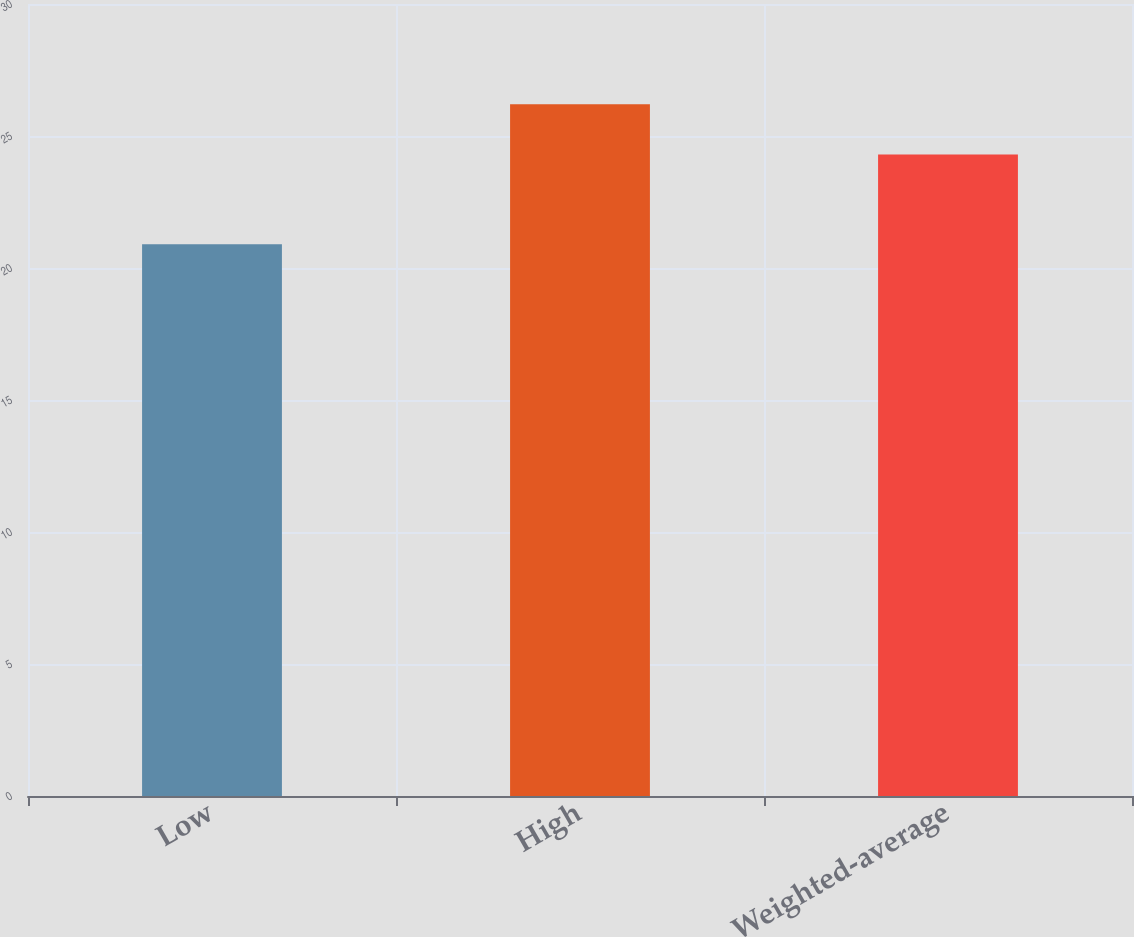<chart> <loc_0><loc_0><loc_500><loc_500><bar_chart><fcel>Low<fcel>High<fcel>Weighted-average<nl><fcel>20.9<fcel>26.2<fcel>24.3<nl></chart> 